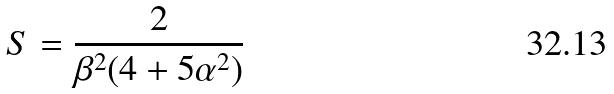<formula> <loc_0><loc_0><loc_500><loc_500>S = \frac { 2 } { \beta ^ { 2 } ( 4 + 5 \alpha ^ { 2 } ) }</formula> 